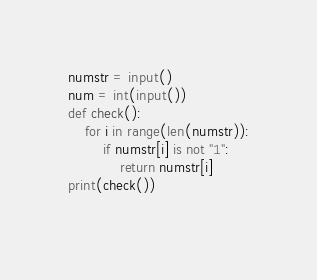Convert code to text. <code><loc_0><loc_0><loc_500><loc_500><_Python_>numstr = input()
num = int(input())
def check():
    for i in range(len(numstr)):
        if numstr[i] is not "1":
            return numstr[i]
print(check())
        
</code> 